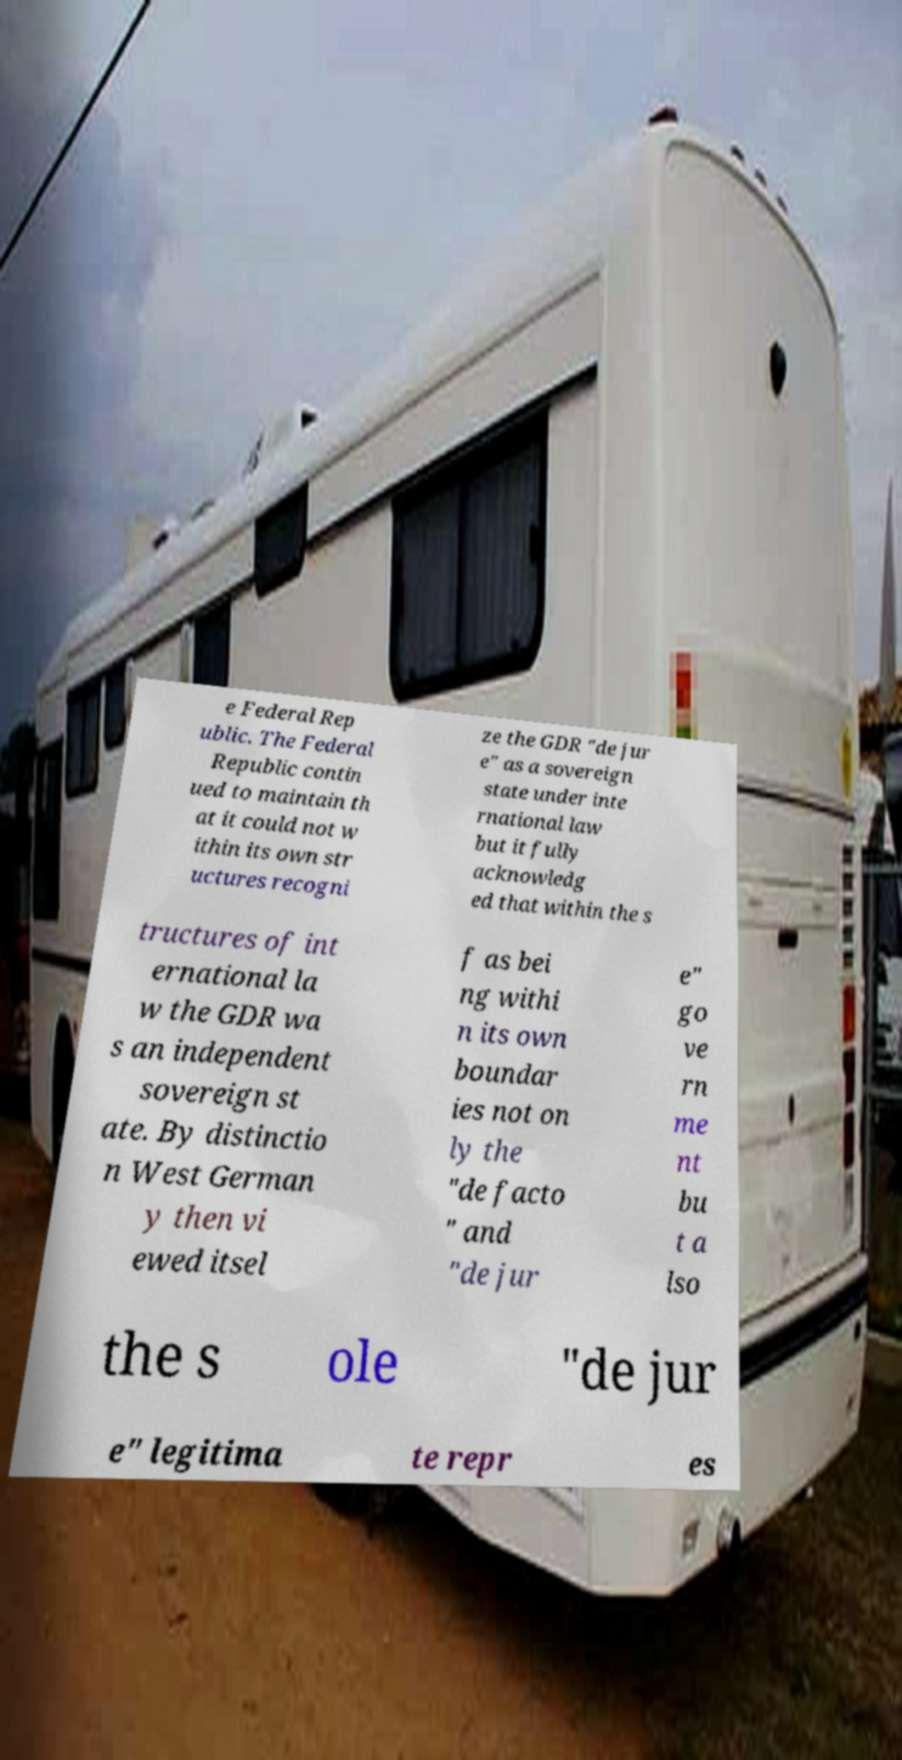What messages or text are displayed in this image? I need them in a readable, typed format. e Federal Rep ublic. The Federal Republic contin ued to maintain th at it could not w ithin its own str uctures recogni ze the GDR "de jur e" as a sovereign state under inte rnational law but it fully acknowledg ed that within the s tructures of int ernational la w the GDR wa s an independent sovereign st ate. By distinctio n West German y then vi ewed itsel f as bei ng withi n its own boundar ies not on ly the "de facto " and "de jur e" go ve rn me nt bu t a lso the s ole "de jur e" legitima te repr es 